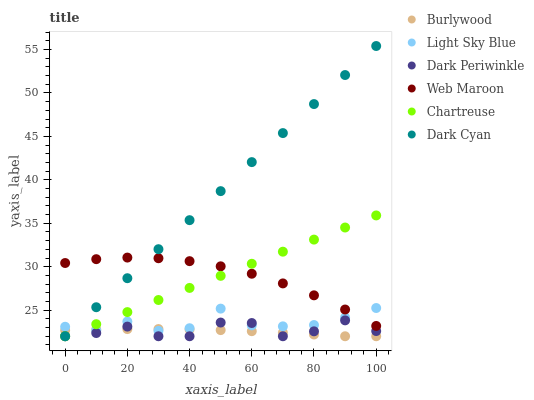Does Burlywood have the minimum area under the curve?
Answer yes or no. Yes. Does Dark Cyan have the maximum area under the curve?
Answer yes or no. Yes. Does Web Maroon have the minimum area under the curve?
Answer yes or no. No. Does Web Maroon have the maximum area under the curve?
Answer yes or no. No. Is Chartreuse the smoothest?
Answer yes or no. Yes. Is Light Sky Blue the roughest?
Answer yes or no. Yes. Is Web Maroon the smoothest?
Answer yes or no. No. Is Web Maroon the roughest?
Answer yes or no. No. Does Burlywood have the lowest value?
Answer yes or no. Yes. Does Web Maroon have the lowest value?
Answer yes or no. No. Does Dark Cyan have the highest value?
Answer yes or no. Yes. Does Web Maroon have the highest value?
Answer yes or no. No. Is Burlywood less than Web Maroon?
Answer yes or no. Yes. Is Web Maroon greater than Dark Periwinkle?
Answer yes or no. Yes. Does Light Sky Blue intersect Dark Periwinkle?
Answer yes or no. Yes. Is Light Sky Blue less than Dark Periwinkle?
Answer yes or no. No. Is Light Sky Blue greater than Dark Periwinkle?
Answer yes or no. No. Does Burlywood intersect Web Maroon?
Answer yes or no. No. 